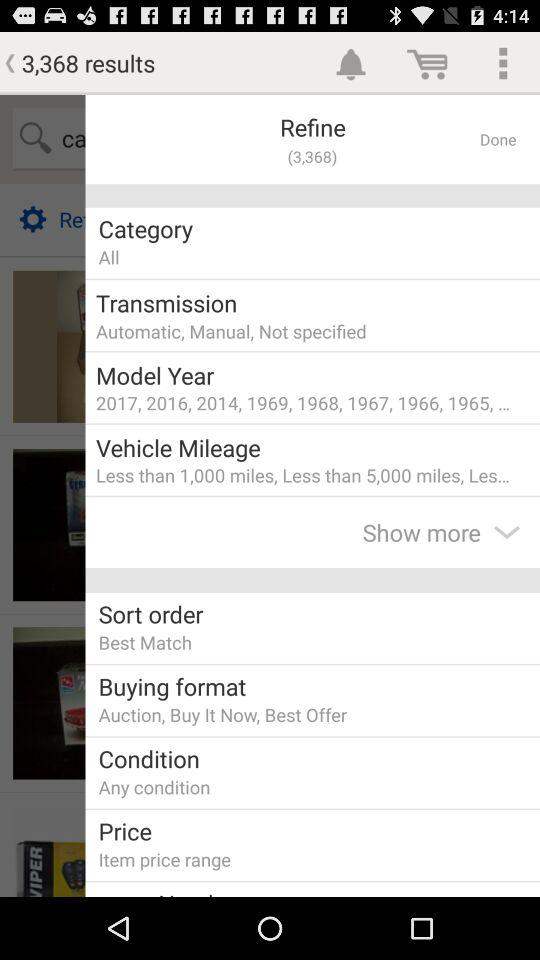What is the vehicle's mileage? The vehicle's mileages are less than 1,000 miles and less than 5,000 miles. 